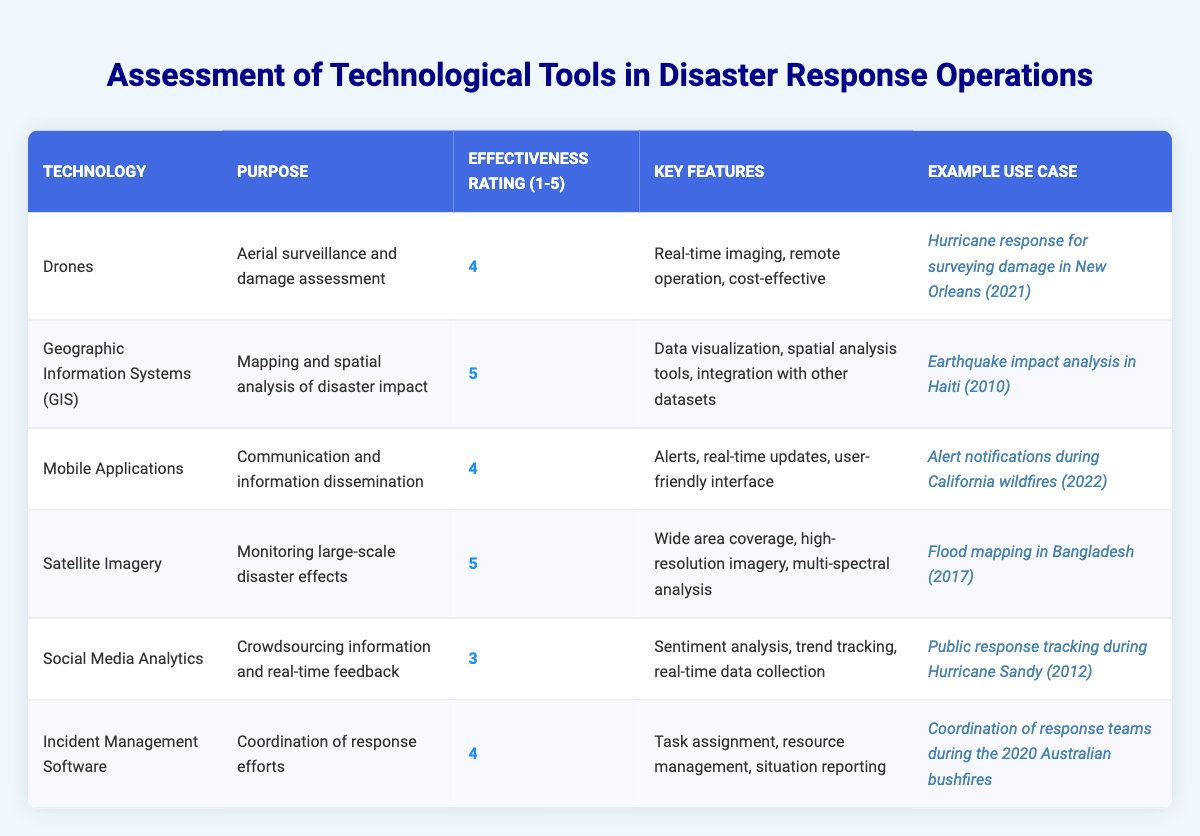What is the effectiveness rating of Drones? The effectiveness rating of Drones is listed as 4 in the table.
Answer: 4 What is the purpose of Geographic Information Systems? The table states that the purpose of Geographic Information Systems is mapping and spatial analysis of disaster impact.
Answer: Mapping and spatial analysis of disaster impact Which technology has the highest effectiveness rating? By comparing all the effectiveness ratings, Geographic Information Systems and Satellite Imagery both have the highest rating of 5.
Answer: Geographic Information Systems and Satellite Imagery What percentage of the technologies listed have an effectiveness rating of 4 or higher? There are 6 technologies listed. Out of these, 4 have ratings of 4 or higher (Drones, Mobile Applications, Satellite Imagery, Incident Management Software). Therefore, (4/6) * 100 = 66.67%.
Answer: 66.67% Is the effectiveness rating of Social Media Analytics greater than 3? The effectiveness rating of Social Media Analytics is 3, which is not greater than 3. Therefore, it is false.
Answer: No What is the key feature of Satellite Imagery? The key features of Satellite Imagery include wide area coverage, high-resolution imagery, and multi-spectral analysis, as indicated in the table.
Answer: Wide area coverage, high-resolution imagery, multi-spectral analysis Which technology was used for public response tracking during Hurricane Sandy? The technology listed in the table for public response tracking during Hurricane Sandy is Social Media Analytics.
Answer: Social Media Analytics If the effectiveness rating for Mobile Applications is 4, and the rating for Incident Management Software is also 4, what is their average effectiveness rating? To find the average, add the two ratings (4 + 4 = 8) and divide by 2, giving 8/2 = 4.
Answer: 4 Was there any technology used for aerial surveillance? Yes, Drones are specifically mentioned for aerial surveillance in the table.
Answer: Yes What example use case is associated with Incident Management Software? The example use case for Incident Management Software, according to the table, is coordination of response teams during the 2020 Australian bushfires.
Answer: Coordination of response teams during the 2020 Australian bushfires 